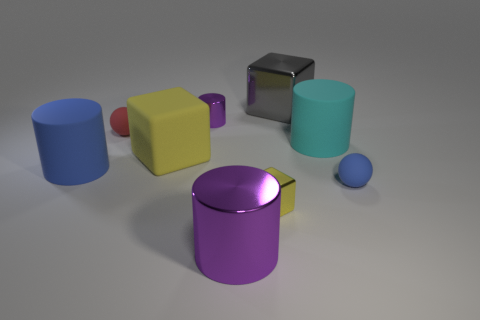Subtract all yellow cubes. How many cubes are left? 1 Subtract all purple balls. How many yellow cubes are left? 2 Add 1 tiny yellow metallic blocks. How many objects exist? 10 Subtract all blue cylinders. How many cylinders are left? 3 Subtract all balls. How many objects are left? 7 Subtract 1 balls. How many balls are left? 1 Subtract all small brown rubber cubes. Subtract all big cyan things. How many objects are left? 8 Add 4 big metallic cylinders. How many big metallic cylinders are left? 5 Add 6 small red matte objects. How many small red matte objects exist? 7 Subtract 0 yellow cylinders. How many objects are left? 9 